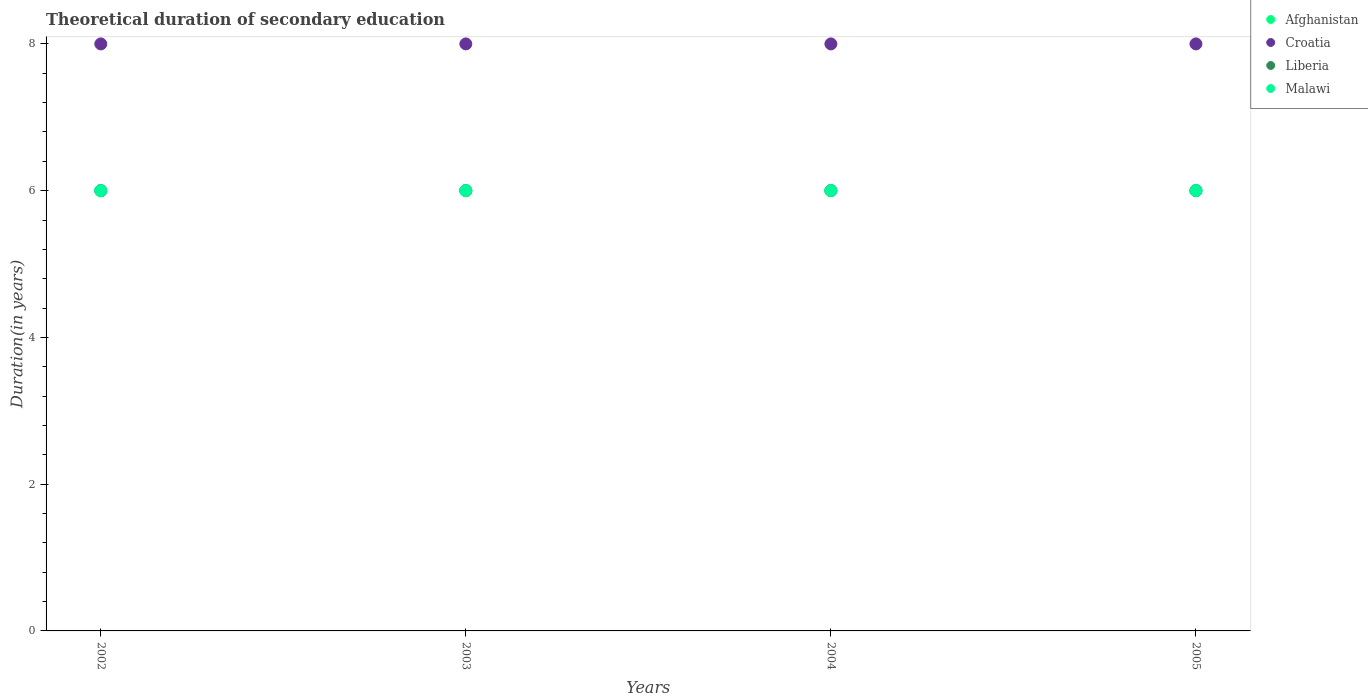How many different coloured dotlines are there?
Make the answer very short. 4. In which year was the total theoretical duration of secondary education in Afghanistan maximum?
Keep it short and to the point. 2002. What is the total total theoretical duration of secondary education in Afghanistan in the graph?
Provide a short and direct response. 24. What is the difference between the total theoretical duration of secondary education in Malawi in 2004 and that in 2005?
Give a very brief answer. 0. What is the difference between the total theoretical duration of secondary education in Malawi in 2003 and the total theoretical duration of secondary education in Afghanistan in 2005?
Make the answer very short. 0. What is the average total theoretical duration of secondary education in Afghanistan per year?
Make the answer very short. 6. In the year 2005, what is the difference between the total theoretical duration of secondary education in Croatia and total theoretical duration of secondary education in Malawi?
Offer a very short reply. 2. In how many years, is the total theoretical duration of secondary education in Liberia greater than 4.4 years?
Offer a very short reply. 4. What is the ratio of the total theoretical duration of secondary education in Afghanistan in 2003 to that in 2005?
Make the answer very short. 1. What is the difference between the highest and the second highest total theoretical duration of secondary education in Malawi?
Your answer should be compact. 0. Is the sum of the total theoretical duration of secondary education in Afghanistan in 2004 and 2005 greater than the maximum total theoretical duration of secondary education in Malawi across all years?
Make the answer very short. Yes. Does the total theoretical duration of secondary education in Liberia monotonically increase over the years?
Your response must be concise. No. How many dotlines are there?
Your answer should be compact. 4. What is the difference between two consecutive major ticks on the Y-axis?
Offer a terse response. 2. Does the graph contain any zero values?
Your answer should be compact. No. How many legend labels are there?
Offer a very short reply. 4. How are the legend labels stacked?
Provide a succinct answer. Vertical. What is the title of the graph?
Give a very brief answer. Theoretical duration of secondary education. Does "Ethiopia" appear as one of the legend labels in the graph?
Keep it short and to the point. No. What is the label or title of the X-axis?
Offer a terse response. Years. What is the label or title of the Y-axis?
Make the answer very short. Duration(in years). What is the Duration(in years) of Afghanistan in 2002?
Offer a terse response. 6. What is the Duration(in years) in Croatia in 2002?
Offer a very short reply. 8. What is the Duration(in years) of Malawi in 2002?
Make the answer very short. 6. What is the Duration(in years) of Afghanistan in 2003?
Provide a succinct answer. 6. What is the Duration(in years) in Malawi in 2003?
Your answer should be very brief. 6. What is the Duration(in years) in Croatia in 2004?
Ensure brevity in your answer.  8. What is the Duration(in years) in Malawi in 2004?
Your answer should be very brief. 6. What is the Duration(in years) in Croatia in 2005?
Offer a terse response. 8. What is the Duration(in years) in Liberia in 2005?
Ensure brevity in your answer.  6. Across all years, what is the maximum Duration(in years) of Croatia?
Offer a very short reply. 8. What is the total Duration(in years) in Afghanistan in the graph?
Provide a short and direct response. 24. What is the total Duration(in years) of Liberia in the graph?
Make the answer very short. 24. What is the difference between the Duration(in years) in Afghanistan in 2002 and that in 2003?
Offer a very short reply. 0. What is the difference between the Duration(in years) of Croatia in 2002 and that in 2003?
Your response must be concise. 0. What is the difference between the Duration(in years) in Liberia in 2002 and that in 2003?
Offer a terse response. 0. What is the difference between the Duration(in years) in Liberia in 2002 and that in 2004?
Your response must be concise. 0. What is the difference between the Duration(in years) in Afghanistan in 2002 and that in 2005?
Provide a succinct answer. 0. What is the difference between the Duration(in years) in Liberia in 2002 and that in 2005?
Your answer should be compact. 0. What is the difference between the Duration(in years) in Malawi in 2002 and that in 2005?
Your answer should be very brief. 0. What is the difference between the Duration(in years) of Afghanistan in 2003 and that in 2004?
Keep it short and to the point. 0. What is the difference between the Duration(in years) of Liberia in 2003 and that in 2004?
Offer a very short reply. 0. What is the difference between the Duration(in years) of Malawi in 2003 and that in 2004?
Provide a succinct answer. 0. What is the difference between the Duration(in years) in Afghanistan in 2003 and that in 2005?
Provide a succinct answer. 0. What is the difference between the Duration(in years) of Malawi in 2003 and that in 2005?
Your answer should be very brief. 0. What is the difference between the Duration(in years) in Croatia in 2004 and that in 2005?
Provide a succinct answer. 0. What is the difference between the Duration(in years) in Liberia in 2004 and that in 2005?
Make the answer very short. 0. What is the difference between the Duration(in years) of Malawi in 2004 and that in 2005?
Make the answer very short. 0. What is the difference between the Duration(in years) in Afghanistan in 2002 and the Duration(in years) in Malawi in 2003?
Provide a short and direct response. 0. What is the difference between the Duration(in years) of Croatia in 2002 and the Duration(in years) of Liberia in 2003?
Keep it short and to the point. 2. What is the difference between the Duration(in years) of Croatia in 2002 and the Duration(in years) of Malawi in 2003?
Your answer should be very brief. 2. What is the difference between the Duration(in years) of Liberia in 2002 and the Duration(in years) of Malawi in 2003?
Provide a short and direct response. 0. What is the difference between the Duration(in years) of Afghanistan in 2002 and the Duration(in years) of Liberia in 2004?
Your answer should be compact. 0. What is the difference between the Duration(in years) of Afghanistan in 2002 and the Duration(in years) of Malawi in 2004?
Provide a succinct answer. 0. What is the difference between the Duration(in years) of Croatia in 2002 and the Duration(in years) of Liberia in 2004?
Ensure brevity in your answer.  2. What is the difference between the Duration(in years) in Croatia in 2002 and the Duration(in years) in Malawi in 2004?
Make the answer very short. 2. What is the difference between the Duration(in years) in Afghanistan in 2002 and the Duration(in years) in Croatia in 2005?
Keep it short and to the point. -2. What is the difference between the Duration(in years) in Croatia in 2002 and the Duration(in years) in Malawi in 2005?
Provide a short and direct response. 2. What is the difference between the Duration(in years) in Afghanistan in 2003 and the Duration(in years) in Malawi in 2004?
Provide a short and direct response. 0. What is the difference between the Duration(in years) of Afghanistan in 2003 and the Duration(in years) of Liberia in 2005?
Provide a succinct answer. 0. What is the difference between the Duration(in years) of Afghanistan in 2003 and the Duration(in years) of Malawi in 2005?
Ensure brevity in your answer.  0. What is the difference between the Duration(in years) in Croatia in 2003 and the Duration(in years) in Liberia in 2005?
Your response must be concise. 2. What is the difference between the Duration(in years) of Liberia in 2003 and the Duration(in years) of Malawi in 2005?
Offer a very short reply. 0. What is the difference between the Duration(in years) of Afghanistan in 2004 and the Duration(in years) of Croatia in 2005?
Keep it short and to the point. -2. What is the difference between the Duration(in years) of Afghanistan in 2004 and the Duration(in years) of Liberia in 2005?
Offer a terse response. 0. What is the difference between the Duration(in years) in Afghanistan in 2004 and the Duration(in years) in Malawi in 2005?
Your answer should be compact. 0. What is the difference between the Duration(in years) in Croatia in 2004 and the Duration(in years) in Malawi in 2005?
Give a very brief answer. 2. What is the difference between the Duration(in years) in Liberia in 2004 and the Duration(in years) in Malawi in 2005?
Your answer should be compact. 0. What is the average Duration(in years) of Afghanistan per year?
Offer a terse response. 6. What is the average Duration(in years) of Liberia per year?
Provide a succinct answer. 6. What is the average Duration(in years) in Malawi per year?
Ensure brevity in your answer.  6. In the year 2002, what is the difference between the Duration(in years) in Afghanistan and Duration(in years) in Liberia?
Ensure brevity in your answer.  0. In the year 2002, what is the difference between the Duration(in years) in Afghanistan and Duration(in years) in Malawi?
Provide a succinct answer. 0. In the year 2002, what is the difference between the Duration(in years) of Croatia and Duration(in years) of Liberia?
Provide a succinct answer. 2. In the year 2003, what is the difference between the Duration(in years) of Afghanistan and Duration(in years) of Malawi?
Provide a succinct answer. 0. In the year 2003, what is the difference between the Duration(in years) in Croatia and Duration(in years) in Liberia?
Offer a very short reply. 2. In the year 2003, what is the difference between the Duration(in years) in Croatia and Duration(in years) in Malawi?
Keep it short and to the point. 2. In the year 2003, what is the difference between the Duration(in years) of Liberia and Duration(in years) of Malawi?
Provide a succinct answer. 0. In the year 2004, what is the difference between the Duration(in years) of Afghanistan and Duration(in years) of Liberia?
Provide a succinct answer. 0. In the year 2004, what is the difference between the Duration(in years) in Croatia and Duration(in years) in Liberia?
Your answer should be very brief. 2. In the year 2004, what is the difference between the Duration(in years) of Croatia and Duration(in years) of Malawi?
Offer a very short reply. 2. In the year 2005, what is the difference between the Duration(in years) of Afghanistan and Duration(in years) of Malawi?
Your answer should be very brief. 0. What is the ratio of the Duration(in years) of Afghanistan in 2002 to that in 2003?
Give a very brief answer. 1. What is the ratio of the Duration(in years) in Liberia in 2002 to that in 2003?
Provide a short and direct response. 1. What is the ratio of the Duration(in years) of Malawi in 2002 to that in 2003?
Provide a short and direct response. 1. What is the ratio of the Duration(in years) in Afghanistan in 2002 to that in 2004?
Keep it short and to the point. 1. What is the ratio of the Duration(in years) in Croatia in 2002 to that in 2004?
Give a very brief answer. 1. What is the ratio of the Duration(in years) of Liberia in 2002 to that in 2004?
Your response must be concise. 1. What is the ratio of the Duration(in years) in Malawi in 2002 to that in 2004?
Give a very brief answer. 1. What is the ratio of the Duration(in years) of Liberia in 2002 to that in 2005?
Offer a terse response. 1. What is the ratio of the Duration(in years) in Malawi in 2002 to that in 2005?
Provide a short and direct response. 1. What is the ratio of the Duration(in years) in Malawi in 2003 to that in 2004?
Your answer should be compact. 1. What is the ratio of the Duration(in years) in Afghanistan in 2003 to that in 2005?
Make the answer very short. 1. What is the ratio of the Duration(in years) in Malawi in 2003 to that in 2005?
Offer a very short reply. 1. What is the ratio of the Duration(in years) of Afghanistan in 2004 to that in 2005?
Give a very brief answer. 1. What is the ratio of the Duration(in years) in Malawi in 2004 to that in 2005?
Your answer should be compact. 1. What is the difference between the highest and the lowest Duration(in years) in Croatia?
Offer a very short reply. 0. What is the difference between the highest and the lowest Duration(in years) of Malawi?
Your answer should be compact. 0. 